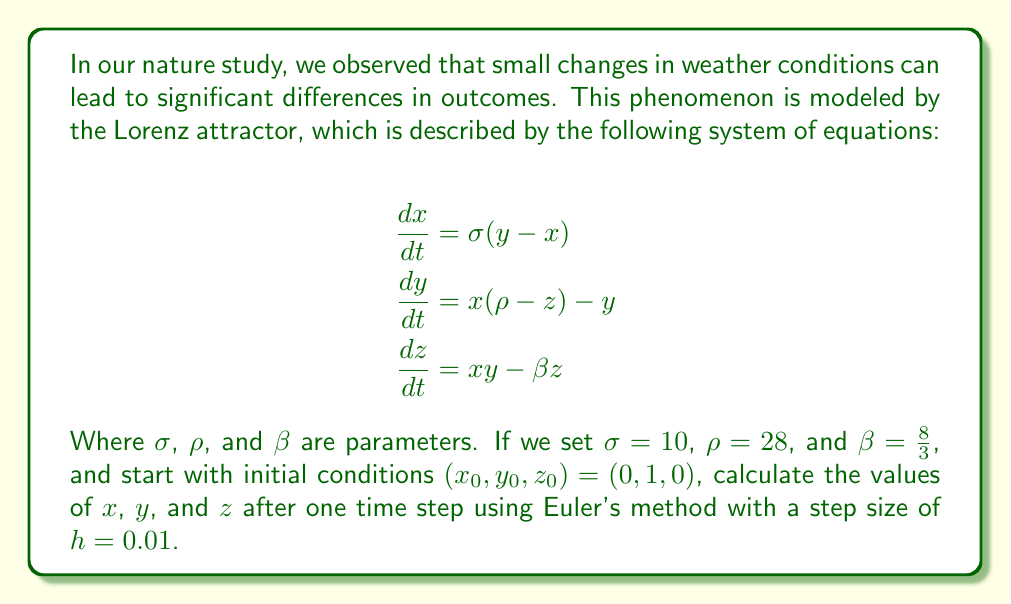Can you answer this question? Let's approach this step-by-step, using Euler's method to approximate the solution:

1) Euler's method is given by the formula:
   $$(x_{n+1}, y_{n+1}, z_{n+1}) = (x_n, y_n, z_n) + h \cdot (f_1(x_n, y_n, z_n), f_2(x_n, y_n, z_n), f_3(x_n, y_n, z_n))$$
   where $f_1$, $f_2$, and $f_3$ are the right-hand sides of the Lorenz equations.

2) We're given:
   $\sigma = 10$, $\rho = 28$, $\beta = \frac{8}{3}$, $h = 0.01$, and $(x_0, y_0, z_0) = (0, 1, 0)$

3) Let's calculate $f_1$, $f_2$, and $f_3$ at the initial point:

   $f_1(0, 1, 0) = 10(1 - 0) = 10$
   $f_2(0, 1, 0) = 0(28 - 0) - 1 = -1$
   $f_3(0, 1, 0) = 0 \cdot 1 - \frac{8}{3} \cdot 0 = 0$

4) Now we can apply Euler's method:

   $x_1 = 0 + 0.01 \cdot 10 = 0.1$
   $y_1 = 1 + 0.01 \cdot (-1) = 0.99$
   $z_1 = 0 + 0.01 \cdot 0 = 0$

5) Therefore, after one time step, the new values are approximately:
   $(x_1, y_1, z_1) = (0.1, 0.99, 0)$
Answer: $(0.1, 0.99, 0)$ 